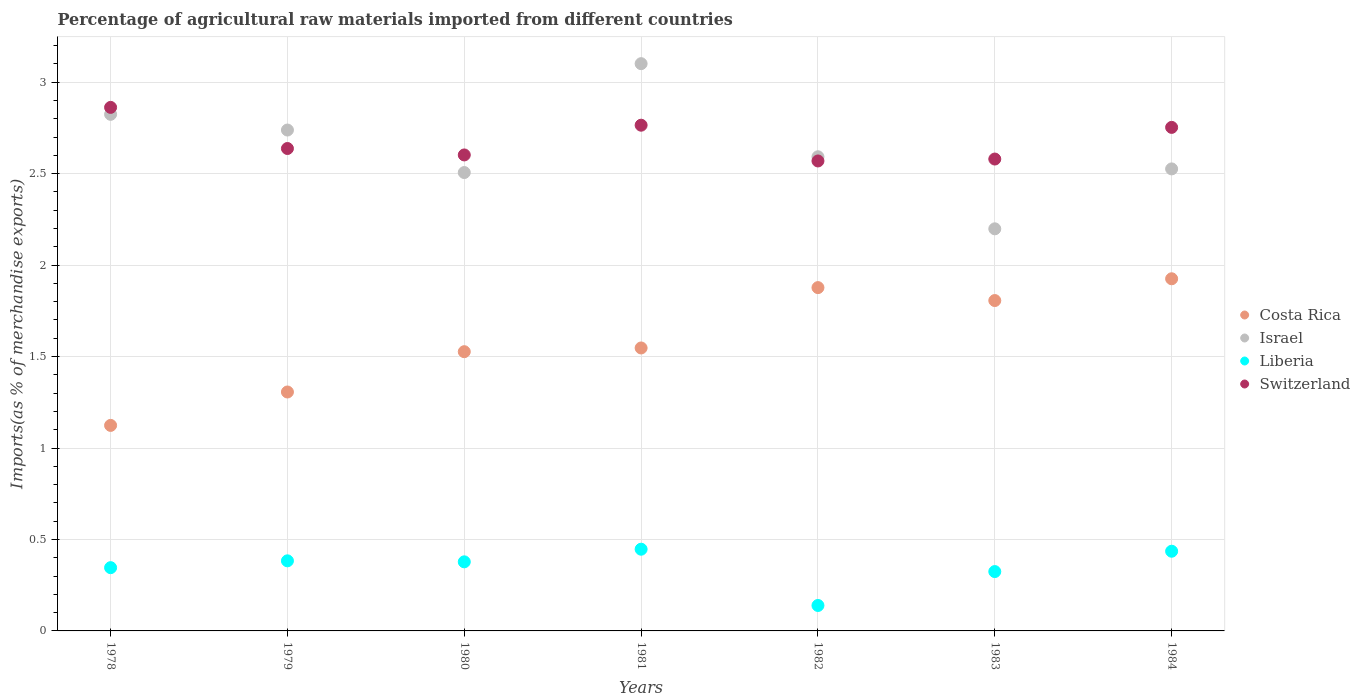What is the percentage of imports to different countries in Liberia in 1979?
Offer a terse response. 0.38. Across all years, what is the maximum percentage of imports to different countries in Costa Rica?
Your response must be concise. 1.93. Across all years, what is the minimum percentage of imports to different countries in Israel?
Your answer should be very brief. 2.2. In which year was the percentage of imports to different countries in Switzerland maximum?
Ensure brevity in your answer.  1978. In which year was the percentage of imports to different countries in Costa Rica minimum?
Keep it short and to the point. 1978. What is the total percentage of imports to different countries in Costa Rica in the graph?
Provide a succinct answer. 11.11. What is the difference between the percentage of imports to different countries in Costa Rica in 1978 and that in 1984?
Your response must be concise. -0.8. What is the difference between the percentage of imports to different countries in Israel in 1981 and the percentage of imports to different countries in Liberia in 1982?
Your answer should be very brief. 2.96. What is the average percentage of imports to different countries in Liberia per year?
Offer a terse response. 0.35. In the year 1979, what is the difference between the percentage of imports to different countries in Switzerland and percentage of imports to different countries in Israel?
Offer a very short reply. -0.1. In how many years, is the percentage of imports to different countries in Israel greater than 0.4 %?
Provide a succinct answer. 7. What is the ratio of the percentage of imports to different countries in Israel in 1979 to that in 1981?
Make the answer very short. 0.88. Is the difference between the percentage of imports to different countries in Switzerland in 1978 and 1983 greater than the difference between the percentage of imports to different countries in Israel in 1978 and 1983?
Your answer should be very brief. No. What is the difference between the highest and the second highest percentage of imports to different countries in Costa Rica?
Ensure brevity in your answer.  0.05. What is the difference between the highest and the lowest percentage of imports to different countries in Israel?
Your response must be concise. 0.9. Is the sum of the percentage of imports to different countries in Switzerland in 1979 and 1981 greater than the maximum percentage of imports to different countries in Costa Rica across all years?
Your answer should be very brief. Yes. What is the difference between two consecutive major ticks on the Y-axis?
Your answer should be very brief. 0.5. What is the title of the graph?
Your answer should be very brief. Percentage of agricultural raw materials imported from different countries. Does "Japan" appear as one of the legend labels in the graph?
Provide a succinct answer. No. What is the label or title of the X-axis?
Offer a terse response. Years. What is the label or title of the Y-axis?
Make the answer very short. Imports(as % of merchandise exports). What is the Imports(as % of merchandise exports) in Costa Rica in 1978?
Your response must be concise. 1.12. What is the Imports(as % of merchandise exports) of Israel in 1978?
Give a very brief answer. 2.82. What is the Imports(as % of merchandise exports) of Liberia in 1978?
Offer a terse response. 0.35. What is the Imports(as % of merchandise exports) in Switzerland in 1978?
Provide a succinct answer. 2.86. What is the Imports(as % of merchandise exports) in Costa Rica in 1979?
Keep it short and to the point. 1.31. What is the Imports(as % of merchandise exports) of Israel in 1979?
Provide a short and direct response. 2.74. What is the Imports(as % of merchandise exports) of Liberia in 1979?
Offer a terse response. 0.38. What is the Imports(as % of merchandise exports) in Switzerland in 1979?
Keep it short and to the point. 2.64. What is the Imports(as % of merchandise exports) of Costa Rica in 1980?
Keep it short and to the point. 1.53. What is the Imports(as % of merchandise exports) of Israel in 1980?
Offer a very short reply. 2.51. What is the Imports(as % of merchandise exports) of Liberia in 1980?
Make the answer very short. 0.38. What is the Imports(as % of merchandise exports) in Switzerland in 1980?
Your answer should be compact. 2.6. What is the Imports(as % of merchandise exports) in Costa Rica in 1981?
Your answer should be very brief. 1.55. What is the Imports(as % of merchandise exports) in Israel in 1981?
Give a very brief answer. 3.1. What is the Imports(as % of merchandise exports) of Liberia in 1981?
Make the answer very short. 0.45. What is the Imports(as % of merchandise exports) of Switzerland in 1981?
Keep it short and to the point. 2.76. What is the Imports(as % of merchandise exports) of Costa Rica in 1982?
Provide a short and direct response. 1.88. What is the Imports(as % of merchandise exports) in Israel in 1982?
Make the answer very short. 2.59. What is the Imports(as % of merchandise exports) in Liberia in 1982?
Offer a very short reply. 0.14. What is the Imports(as % of merchandise exports) of Switzerland in 1982?
Your answer should be very brief. 2.57. What is the Imports(as % of merchandise exports) in Costa Rica in 1983?
Your answer should be compact. 1.81. What is the Imports(as % of merchandise exports) in Israel in 1983?
Offer a terse response. 2.2. What is the Imports(as % of merchandise exports) in Liberia in 1983?
Provide a succinct answer. 0.32. What is the Imports(as % of merchandise exports) in Switzerland in 1983?
Provide a short and direct response. 2.58. What is the Imports(as % of merchandise exports) in Costa Rica in 1984?
Provide a succinct answer. 1.93. What is the Imports(as % of merchandise exports) of Israel in 1984?
Provide a succinct answer. 2.53. What is the Imports(as % of merchandise exports) in Liberia in 1984?
Your answer should be very brief. 0.44. What is the Imports(as % of merchandise exports) in Switzerland in 1984?
Offer a terse response. 2.75. Across all years, what is the maximum Imports(as % of merchandise exports) of Costa Rica?
Give a very brief answer. 1.93. Across all years, what is the maximum Imports(as % of merchandise exports) in Israel?
Provide a short and direct response. 3.1. Across all years, what is the maximum Imports(as % of merchandise exports) in Liberia?
Offer a very short reply. 0.45. Across all years, what is the maximum Imports(as % of merchandise exports) in Switzerland?
Offer a very short reply. 2.86. Across all years, what is the minimum Imports(as % of merchandise exports) of Costa Rica?
Your response must be concise. 1.12. Across all years, what is the minimum Imports(as % of merchandise exports) of Israel?
Provide a succinct answer. 2.2. Across all years, what is the minimum Imports(as % of merchandise exports) in Liberia?
Make the answer very short. 0.14. Across all years, what is the minimum Imports(as % of merchandise exports) of Switzerland?
Ensure brevity in your answer.  2.57. What is the total Imports(as % of merchandise exports) in Costa Rica in the graph?
Your answer should be very brief. 11.11. What is the total Imports(as % of merchandise exports) of Israel in the graph?
Offer a terse response. 18.49. What is the total Imports(as % of merchandise exports) of Liberia in the graph?
Offer a terse response. 2.45. What is the total Imports(as % of merchandise exports) in Switzerland in the graph?
Your answer should be very brief. 18.77. What is the difference between the Imports(as % of merchandise exports) of Costa Rica in 1978 and that in 1979?
Make the answer very short. -0.18. What is the difference between the Imports(as % of merchandise exports) of Israel in 1978 and that in 1979?
Ensure brevity in your answer.  0.09. What is the difference between the Imports(as % of merchandise exports) in Liberia in 1978 and that in 1979?
Give a very brief answer. -0.04. What is the difference between the Imports(as % of merchandise exports) of Switzerland in 1978 and that in 1979?
Give a very brief answer. 0.22. What is the difference between the Imports(as % of merchandise exports) of Costa Rica in 1978 and that in 1980?
Provide a succinct answer. -0.4. What is the difference between the Imports(as % of merchandise exports) of Israel in 1978 and that in 1980?
Make the answer very short. 0.32. What is the difference between the Imports(as % of merchandise exports) of Liberia in 1978 and that in 1980?
Offer a terse response. -0.03. What is the difference between the Imports(as % of merchandise exports) of Switzerland in 1978 and that in 1980?
Make the answer very short. 0.26. What is the difference between the Imports(as % of merchandise exports) in Costa Rica in 1978 and that in 1981?
Offer a very short reply. -0.42. What is the difference between the Imports(as % of merchandise exports) of Israel in 1978 and that in 1981?
Keep it short and to the point. -0.28. What is the difference between the Imports(as % of merchandise exports) of Liberia in 1978 and that in 1981?
Make the answer very short. -0.1. What is the difference between the Imports(as % of merchandise exports) in Switzerland in 1978 and that in 1981?
Provide a short and direct response. 0.1. What is the difference between the Imports(as % of merchandise exports) of Costa Rica in 1978 and that in 1982?
Your response must be concise. -0.75. What is the difference between the Imports(as % of merchandise exports) of Israel in 1978 and that in 1982?
Ensure brevity in your answer.  0.23. What is the difference between the Imports(as % of merchandise exports) of Liberia in 1978 and that in 1982?
Provide a succinct answer. 0.21. What is the difference between the Imports(as % of merchandise exports) of Switzerland in 1978 and that in 1982?
Your answer should be very brief. 0.29. What is the difference between the Imports(as % of merchandise exports) of Costa Rica in 1978 and that in 1983?
Your answer should be compact. -0.68. What is the difference between the Imports(as % of merchandise exports) in Israel in 1978 and that in 1983?
Your answer should be compact. 0.63. What is the difference between the Imports(as % of merchandise exports) of Liberia in 1978 and that in 1983?
Give a very brief answer. 0.02. What is the difference between the Imports(as % of merchandise exports) in Switzerland in 1978 and that in 1983?
Your answer should be compact. 0.28. What is the difference between the Imports(as % of merchandise exports) in Costa Rica in 1978 and that in 1984?
Provide a short and direct response. -0.8. What is the difference between the Imports(as % of merchandise exports) in Israel in 1978 and that in 1984?
Your answer should be very brief. 0.3. What is the difference between the Imports(as % of merchandise exports) of Liberia in 1978 and that in 1984?
Ensure brevity in your answer.  -0.09. What is the difference between the Imports(as % of merchandise exports) in Switzerland in 1978 and that in 1984?
Offer a terse response. 0.11. What is the difference between the Imports(as % of merchandise exports) in Costa Rica in 1979 and that in 1980?
Your response must be concise. -0.22. What is the difference between the Imports(as % of merchandise exports) of Israel in 1979 and that in 1980?
Provide a succinct answer. 0.23. What is the difference between the Imports(as % of merchandise exports) in Liberia in 1979 and that in 1980?
Provide a short and direct response. 0.01. What is the difference between the Imports(as % of merchandise exports) of Switzerland in 1979 and that in 1980?
Ensure brevity in your answer.  0.04. What is the difference between the Imports(as % of merchandise exports) of Costa Rica in 1979 and that in 1981?
Provide a short and direct response. -0.24. What is the difference between the Imports(as % of merchandise exports) in Israel in 1979 and that in 1981?
Ensure brevity in your answer.  -0.36. What is the difference between the Imports(as % of merchandise exports) in Liberia in 1979 and that in 1981?
Make the answer very short. -0.06. What is the difference between the Imports(as % of merchandise exports) of Switzerland in 1979 and that in 1981?
Offer a terse response. -0.13. What is the difference between the Imports(as % of merchandise exports) in Costa Rica in 1979 and that in 1982?
Keep it short and to the point. -0.57. What is the difference between the Imports(as % of merchandise exports) of Israel in 1979 and that in 1982?
Offer a very short reply. 0.15. What is the difference between the Imports(as % of merchandise exports) in Liberia in 1979 and that in 1982?
Offer a terse response. 0.24. What is the difference between the Imports(as % of merchandise exports) in Switzerland in 1979 and that in 1982?
Offer a terse response. 0.07. What is the difference between the Imports(as % of merchandise exports) in Costa Rica in 1979 and that in 1983?
Provide a short and direct response. -0.5. What is the difference between the Imports(as % of merchandise exports) in Israel in 1979 and that in 1983?
Provide a succinct answer. 0.54. What is the difference between the Imports(as % of merchandise exports) in Liberia in 1979 and that in 1983?
Keep it short and to the point. 0.06. What is the difference between the Imports(as % of merchandise exports) of Switzerland in 1979 and that in 1983?
Provide a succinct answer. 0.06. What is the difference between the Imports(as % of merchandise exports) of Costa Rica in 1979 and that in 1984?
Your answer should be very brief. -0.62. What is the difference between the Imports(as % of merchandise exports) of Israel in 1979 and that in 1984?
Make the answer very short. 0.21. What is the difference between the Imports(as % of merchandise exports) of Liberia in 1979 and that in 1984?
Keep it short and to the point. -0.05. What is the difference between the Imports(as % of merchandise exports) in Switzerland in 1979 and that in 1984?
Keep it short and to the point. -0.12. What is the difference between the Imports(as % of merchandise exports) in Costa Rica in 1980 and that in 1981?
Keep it short and to the point. -0.02. What is the difference between the Imports(as % of merchandise exports) in Israel in 1980 and that in 1981?
Ensure brevity in your answer.  -0.6. What is the difference between the Imports(as % of merchandise exports) of Liberia in 1980 and that in 1981?
Your answer should be very brief. -0.07. What is the difference between the Imports(as % of merchandise exports) of Switzerland in 1980 and that in 1981?
Offer a terse response. -0.16. What is the difference between the Imports(as % of merchandise exports) of Costa Rica in 1980 and that in 1982?
Your answer should be compact. -0.35. What is the difference between the Imports(as % of merchandise exports) of Israel in 1980 and that in 1982?
Give a very brief answer. -0.09. What is the difference between the Imports(as % of merchandise exports) of Liberia in 1980 and that in 1982?
Offer a terse response. 0.24. What is the difference between the Imports(as % of merchandise exports) of Switzerland in 1980 and that in 1982?
Your answer should be very brief. 0.03. What is the difference between the Imports(as % of merchandise exports) of Costa Rica in 1980 and that in 1983?
Provide a succinct answer. -0.28. What is the difference between the Imports(as % of merchandise exports) of Israel in 1980 and that in 1983?
Ensure brevity in your answer.  0.31. What is the difference between the Imports(as % of merchandise exports) in Liberia in 1980 and that in 1983?
Make the answer very short. 0.05. What is the difference between the Imports(as % of merchandise exports) in Switzerland in 1980 and that in 1983?
Your response must be concise. 0.02. What is the difference between the Imports(as % of merchandise exports) of Costa Rica in 1980 and that in 1984?
Provide a short and direct response. -0.4. What is the difference between the Imports(as % of merchandise exports) in Israel in 1980 and that in 1984?
Your answer should be compact. -0.02. What is the difference between the Imports(as % of merchandise exports) of Liberia in 1980 and that in 1984?
Your response must be concise. -0.06. What is the difference between the Imports(as % of merchandise exports) in Switzerland in 1980 and that in 1984?
Offer a terse response. -0.15. What is the difference between the Imports(as % of merchandise exports) of Costa Rica in 1981 and that in 1982?
Make the answer very short. -0.33. What is the difference between the Imports(as % of merchandise exports) of Israel in 1981 and that in 1982?
Provide a short and direct response. 0.51. What is the difference between the Imports(as % of merchandise exports) in Liberia in 1981 and that in 1982?
Offer a very short reply. 0.31. What is the difference between the Imports(as % of merchandise exports) of Switzerland in 1981 and that in 1982?
Keep it short and to the point. 0.2. What is the difference between the Imports(as % of merchandise exports) in Costa Rica in 1981 and that in 1983?
Your response must be concise. -0.26. What is the difference between the Imports(as % of merchandise exports) of Israel in 1981 and that in 1983?
Provide a succinct answer. 0.9. What is the difference between the Imports(as % of merchandise exports) in Liberia in 1981 and that in 1983?
Your answer should be compact. 0.12. What is the difference between the Imports(as % of merchandise exports) of Switzerland in 1981 and that in 1983?
Make the answer very short. 0.18. What is the difference between the Imports(as % of merchandise exports) of Costa Rica in 1981 and that in 1984?
Make the answer very short. -0.38. What is the difference between the Imports(as % of merchandise exports) of Israel in 1981 and that in 1984?
Give a very brief answer. 0.58. What is the difference between the Imports(as % of merchandise exports) in Liberia in 1981 and that in 1984?
Give a very brief answer. 0.01. What is the difference between the Imports(as % of merchandise exports) of Switzerland in 1981 and that in 1984?
Provide a succinct answer. 0.01. What is the difference between the Imports(as % of merchandise exports) of Costa Rica in 1982 and that in 1983?
Your answer should be compact. 0.07. What is the difference between the Imports(as % of merchandise exports) in Israel in 1982 and that in 1983?
Your answer should be compact. 0.39. What is the difference between the Imports(as % of merchandise exports) of Liberia in 1982 and that in 1983?
Your response must be concise. -0.19. What is the difference between the Imports(as % of merchandise exports) in Switzerland in 1982 and that in 1983?
Provide a short and direct response. -0.01. What is the difference between the Imports(as % of merchandise exports) in Costa Rica in 1982 and that in 1984?
Your response must be concise. -0.05. What is the difference between the Imports(as % of merchandise exports) of Israel in 1982 and that in 1984?
Offer a very short reply. 0.07. What is the difference between the Imports(as % of merchandise exports) of Liberia in 1982 and that in 1984?
Your answer should be very brief. -0.3. What is the difference between the Imports(as % of merchandise exports) of Switzerland in 1982 and that in 1984?
Provide a short and direct response. -0.18. What is the difference between the Imports(as % of merchandise exports) of Costa Rica in 1983 and that in 1984?
Keep it short and to the point. -0.12. What is the difference between the Imports(as % of merchandise exports) in Israel in 1983 and that in 1984?
Ensure brevity in your answer.  -0.33. What is the difference between the Imports(as % of merchandise exports) in Liberia in 1983 and that in 1984?
Offer a terse response. -0.11. What is the difference between the Imports(as % of merchandise exports) in Switzerland in 1983 and that in 1984?
Make the answer very short. -0.17. What is the difference between the Imports(as % of merchandise exports) in Costa Rica in 1978 and the Imports(as % of merchandise exports) in Israel in 1979?
Your response must be concise. -1.61. What is the difference between the Imports(as % of merchandise exports) of Costa Rica in 1978 and the Imports(as % of merchandise exports) of Liberia in 1979?
Give a very brief answer. 0.74. What is the difference between the Imports(as % of merchandise exports) in Costa Rica in 1978 and the Imports(as % of merchandise exports) in Switzerland in 1979?
Provide a short and direct response. -1.51. What is the difference between the Imports(as % of merchandise exports) in Israel in 1978 and the Imports(as % of merchandise exports) in Liberia in 1979?
Your answer should be very brief. 2.44. What is the difference between the Imports(as % of merchandise exports) of Israel in 1978 and the Imports(as % of merchandise exports) of Switzerland in 1979?
Your answer should be very brief. 0.19. What is the difference between the Imports(as % of merchandise exports) of Liberia in 1978 and the Imports(as % of merchandise exports) of Switzerland in 1979?
Your answer should be very brief. -2.29. What is the difference between the Imports(as % of merchandise exports) in Costa Rica in 1978 and the Imports(as % of merchandise exports) in Israel in 1980?
Provide a short and direct response. -1.38. What is the difference between the Imports(as % of merchandise exports) in Costa Rica in 1978 and the Imports(as % of merchandise exports) in Liberia in 1980?
Offer a terse response. 0.75. What is the difference between the Imports(as % of merchandise exports) in Costa Rica in 1978 and the Imports(as % of merchandise exports) in Switzerland in 1980?
Ensure brevity in your answer.  -1.48. What is the difference between the Imports(as % of merchandise exports) of Israel in 1978 and the Imports(as % of merchandise exports) of Liberia in 1980?
Your answer should be compact. 2.45. What is the difference between the Imports(as % of merchandise exports) of Israel in 1978 and the Imports(as % of merchandise exports) of Switzerland in 1980?
Offer a terse response. 0.22. What is the difference between the Imports(as % of merchandise exports) of Liberia in 1978 and the Imports(as % of merchandise exports) of Switzerland in 1980?
Provide a short and direct response. -2.26. What is the difference between the Imports(as % of merchandise exports) in Costa Rica in 1978 and the Imports(as % of merchandise exports) in Israel in 1981?
Your response must be concise. -1.98. What is the difference between the Imports(as % of merchandise exports) of Costa Rica in 1978 and the Imports(as % of merchandise exports) of Liberia in 1981?
Provide a short and direct response. 0.68. What is the difference between the Imports(as % of merchandise exports) of Costa Rica in 1978 and the Imports(as % of merchandise exports) of Switzerland in 1981?
Offer a very short reply. -1.64. What is the difference between the Imports(as % of merchandise exports) of Israel in 1978 and the Imports(as % of merchandise exports) of Liberia in 1981?
Your answer should be compact. 2.38. What is the difference between the Imports(as % of merchandise exports) in Israel in 1978 and the Imports(as % of merchandise exports) in Switzerland in 1981?
Provide a short and direct response. 0.06. What is the difference between the Imports(as % of merchandise exports) in Liberia in 1978 and the Imports(as % of merchandise exports) in Switzerland in 1981?
Ensure brevity in your answer.  -2.42. What is the difference between the Imports(as % of merchandise exports) in Costa Rica in 1978 and the Imports(as % of merchandise exports) in Israel in 1982?
Your answer should be compact. -1.47. What is the difference between the Imports(as % of merchandise exports) in Costa Rica in 1978 and the Imports(as % of merchandise exports) in Liberia in 1982?
Your answer should be very brief. 0.98. What is the difference between the Imports(as % of merchandise exports) of Costa Rica in 1978 and the Imports(as % of merchandise exports) of Switzerland in 1982?
Your answer should be compact. -1.45. What is the difference between the Imports(as % of merchandise exports) in Israel in 1978 and the Imports(as % of merchandise exports) in Liberia in 1982?
Your answer should be compact. 2.69. What is the difference between the Imports(as % of merchandise exports) of Israel in 1978 and the Imports(as % of merchandise exports) of Switzerland in 1982?
Offer a terse response. 0.26. What is the difference between the Imports(as % of merchandise exports) in Liberia in 1978 and the Imports(as % of merchandise exports) in Switzerland in 1982?
Provide a succinct answer. -2.22. What is the difference between the Imports(as % of merchandise exports) in Costa Rica in 1978 and the Imports(as % of merchandise exports) in Israel in 1983?
Offer a terse response. -1.07. What is the difference between the Imports(as % of merchandise exports) in Costa Rica in 1978 and the Imports(as % of merchandise exports) in Liberia in 1983?
Your response must be concise. 0.8. What is the difference between the Imports(as % of merchandise exports) in Costa Rica in 1978 and the Imports(as % of merchandise exports) in Switzerland in 1983?
Offer a very short reply. -1.46. What is the difference between the Imports(as % of merchandise exports) of Israel in 1978 and the Imports(as % of merchandise exports) of Liberia in 1983?
Give a very brief answer. 2.5. What is the difference between the Imports(as % of merchandise exports) in Israel in 1978 and the Imports(as % of merchandise exports) in Switzerland in 1983?
Your answer should be very brief. 0.24. What is the difference between the Imports(as % of merchandise exports) in Liberia in 1978 and the Imports(as % of merchandise exports) in Switzerland in 1983?
Your response must be concise. -2.23. What is the difference between the Imports(as % of merchandise exports) in Costa Rica in 1978 and the Imports(as % of merchandise exports) in Israel in 1984?
Give a very brief answer. -1.4. What is the difference between the Imports(as % of merchandise exports) of Costa Rica in 1978 and the Imports(as % of merchandise exports) of Liberia in 1984?
Offer a very short reply. 0.69. What is the difference between the Imports(as % of merchandise exports) of Costa Rica in 1978 and the Imports(as % of merchandise exports) of Switzerland in 1984?
Ensure brevity in your answer.  -1.63. What is the difference between the Imports(as % of merchandise exports) in Israel in 1978 and the Imports(as % of merchandise exports) in Liberia in 1984?
Provide a succinct answer. 2.39. What is the difference between the Imports(as % of merchandise exports) of Israel in 1978 and the Imports(as % of merchandise exports) of Switzerland in 1984?
Your response must be concise. 0.07. What is the difference between the Imports(as % of merchandise exports) in Liberia in 1978 and the Imports(as % of merchandise exports) in Switzerland in 1984?
Your answer should be compact. -2.41. What is the difference between the Imports(as % of merchandise exports) of Costa Rica in 1979 and the Imports(as % of merchandise exports) of Israel in 1980?
Make the answer very short. -1.2. What is the difference between the Imports(as % of merchandise exports) in Costa Rica in 1979 and the Imports(as % of merchandise exports) in Liberia in 1980?
Your answer should be compact. 0.93. What is the difference between the Imports(as % of merchandise exports) of Costa Rica in 1979 and the Imports(as % of merchandise exports) of Switzerland in 1980?
Provide a succinct answer. -1.3. What is the difference between the Imports(as % of merchandise exports) of Israel in 1979 and the Imports(as % of merchandise exports) of Liberia in 1980?
Provide a short and direct response. 2.36. What is the difference between the Imports(as % of merchandise exports) of Israel in 1979 and the Imports(as % of merchandise exports) of Switzerland in 1980?
Give a very brief answer. 0.14. What is the difference between the Imports(as % of merchandise exports) of Liberia in 1979 and the Imports(as % of merchandise exports) of Switzerland in 1980?
Provide a short and direct response. -2.22. What is the difference between the Imports(as % of merchandise exports) of Costa Rica in 1979 and the Imports(as % of merchandise exports) of Israel in 1981?
Offer a very short reply. -1.79. What is the difference between the Imports(as % of merchandise exports) of Costa Rica in 1979 and the Imports(as % of merchandise exports) of Liberia in 1981?
Make the answer very short. 0.86. What is the difference between the Imports(as % of merchandise exports) of Costa Rica in 1979 and the Imports(as % of merchandise exports) of Switzerland in 1981?
Make the answer very short. -1.46. What is the difference between the Imports(as % of merchandise exports) in Israel in 1979 and the Imports(as % of merchandise exports) in Liberia in 1981?
Ensure brevity in your answer.  2.29. What is the difference between the Imports(as % of merchandise exports) in Israel in 1979 and the Imports(as % of merchandise exports) in Switzerland in 1981?
Keep it short and to the point. -0.03. What is the difference between the Imports(as % of merchandise exports) of Liberia in 1979 and the Imports(as % of merchandise exports) of Switzerland in 1981?
Provide a short and direct response. -2.38. What is the difference between the Imports(as % of merchandise exports) of Costa Rica in 1979 and the Imports(as % of merchandise exports) of Israel in 1982?
Your answer should be compact. -1.29. What is the difference between the Imports(as % of merchandise exports) of Costa Rica in 1979 and the Imports(as % of merchandise exports) of Liberia in 1982?
Provide a succinct answer. 1.17. What is the difference between the Imports(as % of merchandise exports) of Costa Rica in 1979 and the Imports(as % of merchandise exports) of Switzerland in 1982?
Provide a succinct answer. -1.26. What is the difference between the Imports(as % of merchandise exports) of Israel in 1979 and the Imports(as % of merchandise exports) of Liberia in 1982?
Offer a terse response. 2.6. What is the difference between the Imports(as % of merchandise exports) of Israel in 1979 and the Imports(as % of merchandise exports) of Switzerland in 1982?
Keep it short and to the point. 0.17. What is the difference between the Imports(as % of merchandise exports) in Liberia in 1979 and the Imports(as % of merchandise exports) in Switzerland in 1982?
Provide a short and direct response. -2.19. What is the difference between the Imports(as % of merchandise exports) in Costa Rica in 1979 and the Imports(as % of merchandise exports) in Israel in 1983?
Give a very brief answer. -0.89. What is the difference between the Imports(as % of merchandise exports) in Costa Rica in 1979 and the Imports(as % of merchandise exports) in Liberia in 1983?
Your response must be concise. 0.98. What is the difference between the Imports(as % of merchandise exports) of Costa Rica in 1979 and the Imports(as % of merchandise exports) of Switzerland in 1983?
Ensure brevity in your answer.  -1.27. What is the difference between the Imports(as % of merchandise exports) in Israel in 1979 and the Imports(as % of merchandise exports) in Liberia in 1983?
Provide a short and direct response. 2.41. What is the difference between the Imports(as % of merchandise exports) in Israel in 1979 and the Imports(as % of merchandise exports) in Switzerland in 1983?
Offer a terse response. 0.16. What is the difference between the Imports(as % of merchandise exports) of Liberia in 1979 and the Imports(as % of merchandise exports) of Switzerland in 1983?
Your answer should be very brief. -2.2. What is the difference between the Imports(as % of merchandise exports) in Costa Rica in 1979 and the Imports(as % of merchandise exports) in Israel in 1984?
Provide a short and direct response. -1.22. What is the difference between the Imports(as % of merchandise exports) in Costa Rica in 1979 and the Imports(as % of merchandise exports) in Liberia in 1984?
Give a very brief answer. 0.87. What is the difference between the Imports(as % of merchandise exports) in Costa Rica in 1979 and the Imports(as % of merchandise exports) in Switzerland in 1984?
Provide a short and direct response. -1.45. What is the difference between the Imports(as % of merchandise exports) of Israel in 1979 and the Imports(as % of merchandise exports) of Liberia in 1984?
Your answer should be compact. 2.3. What is the difference between the Imports(as % of merchandise exports) of Israel in 1979 and the Imports(as % of merchandise exports) of Switzerland in 1984?
Your answer should be compact. -0.01. What is the difference between the Imports(as % of merchandise exports) of Liberia in 1979 and the Imports(as % of merchandise exports) of Switzerland in 1984?
Keep it short and to the point. -2.37. What is the difference between the Imports(as % of merchandise exports) in Costa Rica in 1980 and the Imports(as % of merchandise exports) in Israel in 1981?
Your response must be concise. -1.57. What is the difference between the Imports(as % of merchandise exports) of Costa Rica in 1980 and the Imports(as % of merchandise exports) of Liberia in 1981?
Give a very brief answer. 1.08. What is the difference between the Imports(as % of merchandise exports) of Costa Rica in 1980 and the Imports(as % of merchandise exports) of Switzerland in 1981?
Keep it short and to the point. -1.24. What is the difference between the Imports(as % of merchandise exports) of Israel in 1980 and the Imports(as % of merchandise exports) of Liberia in 1981?
Offer a very short reply. 2.06. What is the difference between the Imports(as % of merchandise exports) of Israel in 1980 and the Imports(as % of merchandise exports) of Switzerland in 1981?
Provide a succinct answer. -0.26. What is the difference between the Imports(as % of merchandise exports) in Liberia in 1980 and the Imports(as % of merchandise exports) in Switzerland in 1981?
Give a very brief answer. -2.39. What is the difference between the Imports(as % of merchandise exports) of Costa Rica in 1980 and the Imports(as % of merchandise exports) of Israel in 1982?
Make the answer very short. -1.07. What is the difference between the Imports(as % of merchandise exports) of Costa Rica in 1980 and the Imports(as % of merchandise exports) of Liberia in 1982?
Ensure brevity in your answer.  1.39. What is the difference between the Imports(as % of merchandise exports) of Costa Rica in 1980 and the Imports(as % of merchandise exports) of Switzerland in 1982?
Ensure brevity in your answer.  -1.04. What is the difference between the Imports(as % of merchandise exports) of Israel in 1980 and the Imports(as % of merchandise exports) of Liberia in 1982?
Make the answer very short. 2.37. What is the difference between the Imports(as % of merchandise exports) of Israel in 1980 and the Imports(as % of merchandise exports) of Switzerland in 1982?
Your answer should be very brief. -0.06. What is the difference between the Imports(as % of merchandise exports) in Liberia in 1980 and the Imports(as % of merchandise exports) in Switzerland in 1982?
Offer a terse response. -2.19. What is the difference between the Imports(as % of merchandise exports) of Costa Rica in 1980 and the Imports(as % of merchandise exports) of Israel in 1983?
Ensure brevity in your answer.  -0.67. What is the difference between the Imports(as % of merchandise exports) in Costa Rica in 1980 and the Imports(as % of merchandise exports) in Liberia in 1983?
Provide a short and direct response. 1.2. What is the difference between the Imports(as % of merchandise exports) in Costa Rica in 1980 and the Imports(as % of merchandise exports) in Switzerland in 1983?
Make the answer very short. -1.05. What is the difference between the Imports(as % of merchandise exports) of Israel in 1980 and the Imports(as % of merchandise exports) of Liberia in 1983?
Provide a short and direct response. 2.18. What is the difference between the Imports(as % of merchandise exports) of Israel in 1980 and the Imports(as % of merchandise exports) of Switzerland in 1983?
Ensure brevity in your answer.  -0.07. What is the difference between the Imports(as % of merchandise exports) in Liberia in 1980 and the Imports(as % of merchandise exports) in Switzerland in 1983?
Provide a short and direct response. -2.2. What is the difference between the Imports(as % of merchandise exports) in Costa Rica in 1980 and the Imports(as % of merchandise exports) in Israel in 1984?
Provide a short and direct response. -1. What is the difference between the Imports(as % of merchandise exports) in Costa Rica in 1980 and the Imports(as % of merchandise exports) in Liberia in 1984?
Offer a terse response. 1.09. What is the difference between the Imports(as % of merchandise exports) of Costa Rica in 1980 and the Imports(as % of merchandise exports) of Switzerland in 1984?
Your answer should be very brief. -1.23. What is the difference between the Imports(as % of merchandise exports) of Israel in 1980 and the Imports(as % of merchandise exports) of Liberia in 1984?
Your answer should be very brief. 2.07. What is the difference between the Imports(as % of merchandise exports) in Israel in 1980 and the Imports(as % of merchandise exports) in Switzerland in 1984?
Your answer should be very brief. -0.25. What is the difference between the Imports(as % of merchandise exports) of Liberia in 1980 and the Imports(as % of merchandise exports) of Switzerland in 1984?
Give a very brief answer. -2.38. What is the difference between the Imports(as % of merchandise exports) of Costa Rica in 1981 and the Imports(as % of merchandise exports) of Israel in 1982?
Offer a very short reply. -1.05. What is the difference between the Imports(as % of merchandise exports) of Costa Rica in 1981 and the Imports(as % of merchandise exports) of Liberia in 1982?
Make the answer very short. 1.41. What is the difference between the Imports(as % of merchandise exports) of Costa Rica in 1981 and the Imports(as % of merchandise exports) of Switzerland in 1982?
Offer a terse response. -1.02. What is the difference between the Imports(as % of merchandise exports) in Israel in 1981 and the Imports(as % of merchandise exports) in Liberia in 1982?
Your response must be concise. 2.96. What is the difference between the Imports(as % of merchandise exports) in Israel in 1981 and the Imports(as % of merchandise exports) in Switzerland in 1982?
Keep it short and to the point. 0.53. What is the difference between the Imports(as % of merchandise exports) in Liberia in 1981 and the Imports(as % of merchandise exports) in Switzerland in 1982?
Your answer should be very brief. -2.12. What is the difference between the Imports(as % of merchandise exports) of Costa Rica in 1981 and the Imports(as % of merchandise exports) of Israel in 1983?
Keep it short and to the point. -0.65. What is the difference between the Imports(as % of merchandise exports) of Costa Rica in 1981 and the Imports(as % of merchandise exports) of Liberia in 1983?
Ensure brevity in your answer.  1.22. What is the difference between the Imports(as % of merchandise exports) of Costa Rica in 1981 and the Imports(as % of merchandise exports) of Switzerland in 1983?
Offer a very short reply. -1.03. What is the difference between the Imports(as % of merchandise exports) in Israel in 1981 and the Imports(as % of merchandise exports) in Liberia in 1983?
Offer a terse response. 2.78. What is the difference between the Imports(as % of merchandise exports) in Israel in 1981 and the Imports(as % of merchandise exports) in Switzerland in 1983?
Provide a succinct answer. 0.52. What is the difference between the Imports(as % of merchandise exports) in Liberia in 1981 and the Imports(as % of merchandise exports) in Switzerland in 1983?
Offer a very short reply. -2.13. What is the difference between the Imports(as % of merchandise exports) of Costa Rica in 1981 and the Imports(as % of merchandise exports) of Israel in 1984?
Keep it short and to the point. -0.98. What is the difference between the Imports(as % of merchandise exports) of Costa Rica in 1981 and the Imports(as % of merchandise exports) of Liberia in 1984?
Provide a succinct answer. 1.11. What is the difference between the Imports(as % of merchandise exports) in Costa Rica in 1981 and the Imports(as % of merchandise exports) in Switzerland in 1984?
Keep it short and to the point. -1.21. What is the difference between the Imports(as % of merchandise exports) of Israel in 1981 and the Imports(as % of merchandise exports) of Liberia in 1984?
Make the answer very short. 2.67. What is the difference between the Imports(as % of merchandise exports) in Israel in 1981 and the Imports(as % of merchandise exports) in Switzerland in 1984?
Your answer should be compact. 0.35. What is the difference between the Imports(as % of merchandise exports) of Liberia in 1981 and the Imports(as % of merchandise exports) of Switzerland in 1984?
Offer a terse response. -2.31. What is the difference between the Imports(as % of merchandise exports) in Costa Rica in 1982 and the Imports(as % of merchandise exports) in Israel in 1983?
Provide a short and direct response. -0.32. What is the difference between the Imports(as % of merchandise exports) of Costa Rica in 1982 and the Imports(as % of merchandise exports) of Liberia in 1983?
Provide a succinct answer. 1.55. What is the difference between the Imports(as % of merchandise exports) of Costa Rica in 1982 and the Imports(as % of merchandise exports) of Switzerland in 1983?
Offer a very short reply. -0.7. What is the difference between the Imports(as % of merchandise exports) of Israel in 1982 and the Imports(as % of merchandise exports) of Liberia in 1983?
Provide a short and direct response. 2.27. What is the difference between the Imports(as % of merchandise exports) of Israel in 1982 and the Imports(as % of merchandise exports) of Switzerland in 1983?
Offer a very short reply. 0.01. What is the difference between the Imports(as % of merchandise exports) of Liberia in 1982 and the Imports(as % of merchandise exports) of Switzerland in 1983?
Give a very brief answer. -2.44. What is the difference between the Imports(as % of merchandise exports) in Costa Rica in 1982 and the Imports(as % of merchandise exports) in Israel in 1984?
Keep it short and to the point. -0.65. What is the difference between the Imports(as % of merchandise exports) of Costa Rica in 1982 and the Imports(as % of merchandise exports) of Liberia in 1984?
Offer a very short reply. 1.44. What is the difference between the Imports(as % of merchandise exports) in Costa Rica in 1982 and the Imports(as % of merchandise exports) in Switzerland in 1984?
Your answer should be compact. -0.88. What is the difference between the Imports(as % of merchandise exports) of Israel in 1982 and the Imports(as % of merchandise exports) of Liberia in 1984?
Provide a short and direct response. 2.16. What is the difference between the Imports(as % of merchandise exports) in Israel in 1982 and the Imports(as % of merchandise exports) in Switzerland in 1984?
Your answer should be compact. -0.16. What is the difference between the Imports(as % of merchandise exports) in Liberia in 1982 and the Imports(as % of merchandise exports) in Switzerland in 1984?
Provide a short and direct response. -2.61. What is the difference between the Imports(as % of merchandise exports) of Costa Rica in 1983 and the Imports(as % of merchandise exports) of Israel in 1984?
Offer a very short reply. -0.72. What is the difference between the Imports(as % of merchandise exports) in Costa Rica in 1983 and the Imports(as % of merchandise exports) in Liberia in 1984?
Give a very brief answer. 1.37. What is the difference between the Imports(as % of merchandise exports) in Costa Rica in 1983 and the Imports(as % of merchandise exports) in Switzerland in 1984?
Your response must be concise. -0.95. What is the difference between the Imports(as % of merchandise exports) in Israel in 1983 and the Imports(as % of merchandise exports) in Liberia in 1984?
Make the answer very short. 1.76. What is the difference between the Imports(as % of merchandise exports) in Israel in 1983 and the Imports(as % of merchandise exports) in Switzerland in 1984?
Offer a terse response. -0.55. What is the difference between the Imports(as % of merchandise exports) of Liberia in 1983 and the Imports(as % of merchandise exports) of Switzerland in 1984?
Keep it short and to the point. -2.43. What is the average Imports(as % of merchandise exports) of Costa Rica per year?
Provide a succinct answer. 1.59. What is the average Imports(as % of merchandise exports) of Israel per year?
Your answer should be compact. 2.64. What is the average Imports(as % of merchandise exports) in Liberia per year?
Your answer should be compact. 0.35. What is the average Imports(as % of merchandise exports) of Switzerland per year?
Your answer should be very brief. 2.68. In the year 1978, what is the difference between the Imports(as % of merchandise exports) of Costa Rica and Imports(as % of merchandise exports) of Israel?
Give a very brief answer. -1.7. In the year 1978, what is the difference between the Imports(as % of merchandise exports) of Costa Rica and Imports(as % of merchandise exports) of Switzerland?
Your answer should be compact. -1.74. In the year 1978, what is the difference between the Imports(as % of merchandise exports) in Israel and Imports(as % of merchandise exports) in Liberia?
Your answer should be very brief. 2.48. In the year 1978, what is the difference between the Imports(as % of merchandise exports) of Israel and Imports(as % of merchandise exports) of Switzerland?
Your answer should be compact. -0.04. In the year 1978, what is the difference between the Imports(as % of merchandise exports) in Liberia and Imports(as % of merchandise exports) in Switzerland?
Give a very brief answer. -2.52. In the year 1979, what is the difference between the Imports(as % of merchandise exports) of Costa Rica and Imports(as % of merchandise exports) of Israel?
Your answer should be very brief. -1.43. In the year 1979, what is the difference between the Imports(as % of merchandise exports) in Costa Rica and Imports(as % of merchandise exports) in Liberia?
Offer a terse response. 0.92. In the year 1979, what is the difference between the Imports(as % of merchandise exports) of Costa Rica and Imports(as % of merchandise exports) of Switzerland?
Your answer should be compact. -1.33. In the year 1979, what is the difference between the Imports(as % of merchandise exports) of Israel and Imports(as % of merchandise exports) of Liberia?
Keep it short and to the point. 2.36. In the year 1979, what is the difference between the Imports(as % of merchandise exports) in Israel and Imports(as % of merchandise exports) in Switzerland?
Make the answer very short. 0.1. In the year 1979, what is the difference between the Imports(as % of merchandise exports) in Liberia and Imports(as % of merchandise exports) in Switzerland?
Offer a terse response. -2.25. In the year 1980, what is the difference between the Imports(as % of merchandise exports) of Costa Rica and Imports(as % of merchandise exports) of Israel?
Ensure brevity in your answer.  -0.98. In the year 1980, what is the difference between the Imports(as % of merchandise exports) of Costa Rica and Imports(as % of merchandise exports) of Liberia?
Offer a terse response. 1.15. In the year 1980, what is the difference between the Imports(as % of merchandise exports) in Costa Rica and Imports(as % of merchandise exports) in Switzerland?
Provide a short and direct response. -1.08. In the year 1980, what is the difference between the Imports(as % of merchandise exports) of Israel and Imports(as % of merchandise exports) of Liberia?
Keep it short and to the point. 2.13. In the year 1980, what is the difference between the Imports(as % of merchandise exports) in Israel and Imports(as % of merchandise exports) in Switzerland?
Offer a terse response. -0.1. In the year 1980, what is the difference between the Imports(as % of merchandise exports) of Liberia and Imports(as % of merchandise exports) of Switzerland?
Your response must be concise. -2.22. In the year 1981, what is the difference between the Imports(as % of merchandise exports) in Costa Rica and Imports(as % of merchandise exports) in Israel?
Ensure brevity in your answer.  -1.55. In the year 1981, what is the difference between the Imports(as % of merchandise exports) of Costa Rica and Imports(as % of merchandise exports) of Liberia?
Keep it short and to the point. 1.1. In the year 1981, what is the difference between the Imports(as % of merchandise exports) in Costa Rica and Imports(as % of merchandise exports) in Switzerland?
Ensure brevity in your answer.  -1.22. In the year 1981, what is the difference between the Imports(as % of merchandise exports) in Israel and Imports(as % of merchandise exports) in Liberia?
Your response must be concise. 2.65. In the year 1981, what is the difference between the Imports(as % of merchandise exports) in Israel and Imports(as % of merchandise exports) in Switzerland?
Give a very brief answer. 0.34. In the year 1981, what is the difference between the Imports(as % of merchandise exports) in Liberia and Imports(as % of merchandise exports) in Switzerland?
Your response must be concise. -2.32. In the year 1982, what is the difference between the Imports(as % of merchandise exports) of Costa Rica and Imports(as % of merchandise exports) of Israel?
Keep it short and to the point. -0.72. In the year 1982, what is the difference between the Imports(as % of merchandise exports) in Costa Rica and Imports(as % of merchandise exports) in Liberia?
Your answer should be very brief. 1.74. In the year 1982, what is the difference between the Imports(as % of merchandise exports) in Costa Rica and Imports(as % of merchandise exports) in Switzerland?
Ensure brevity in your answer.  -0.69. In the year 1982, what is the difference between the Imports(as % of merchandise exports) in Israel and Imports(as % of merchandise exports) in Liberia?
Ensure brevity in your answer.  2.45. In the year 1982, what is the difference between the Imports(as % of merchandise exports) in Israel and Imports(as % of merchandise exports) in Switzerland?
Ensure brevity in your answer.  0.02. In the year 1982, what is the difference between the Imports(as % of merchandise exports) of Liberia and Imports(as % of merchandise exports) of Switzerland?
Give a very brief answer. -2.43. In the year 1983, what is the difference between the Imports(as % of merchandise exports) in Costa Rica and Imports(as % of merchandise exports) in Israel?
Offer a terse response. -0.39. In the year 1983, what is the difference between the Imports(as % of merchandise exports) of Costa Rica and Imports(as % of merchandise exports) of Liberia?
Your answer should be compact. 1.48. In the year 1983, what is the difference between the Imports(as % of merchandise exports) in Costa Rica and Imports(as % of merchandise exports) in Switzerland?
Your answer should be compact. -0.77. In the year 1983, what is the difference between the Imports(as % of merchandise exports) in Israel and Imports(as % of merchandise exports) in Liberia?
Make the answer very short. 1.87. In the year 1983, what is the difference between the Imports(as % of merchandise exports) in Israel and Imports(as % of merchandise exports) in Switzerland?
Your answer should be compact. -0.38. In the year 1983, what is the difference between the Imports(as % of merchandise exports) of Liberia and Imports(as % of merchandise exports) of Switzerland?
Offer a terse response. -2.26. In the year 1984, what is the difference between the Imports(as % of merchandise exports) in Costa Rica and Imports(as % of merchandise exports) in Israel?
Make the answer very short. -0.6. In the year 1984, what is the difference between the Imports(as % of merchandise exports) of Costa Rica and Imports(as % of merchandise exports) of Liberia?
Your answer should be compact. 1.49. In the year 1984, what is the difference between the Imports(as % of merchandise exports) in Costa Rica and Imports(as % of merchandise exports) in Switzerland?
Offer a very short reply. -0.83. In the year 1984, what is the difference between the Imports(as % of merchandise exports) in Israel and Imports(as % of merchandise exports) in Liberia?
Offer a terse response. 2.09. In the year 1984, what is the difference between the Imports(as % of merchandise exports) of Israel and Imports(as % of merchandise exports) of Switzerland?
Your answer should be compact. -0.23. In the year 1984, what is the difference between the Imports(as % of merchandise exports) of Liberia and Imports(as % of merchandise exports) of Switzerland?
Give a very brief answer. -2.32. What is the ratio of the Imports(as % of merchandise exports) of Costa Rica in 1978 to that in 1979?
Give a very brief answer. 0.86. What is the ratio of the Imports(as % of merchandise exports) of Israel in 1978 to that in 1979?
Give a very brief answer. 1.03. What is the ratio of the Imports(as % of merchandise exports) in Liberia in 1978 to that in 1979?
Your answer should be compact. 0.9. What is the ratio of the Imports(as % of merchandise exports) of Switzerland in 1978 to that in 1979?
Your response must be concise. 1.09. What is the ratio of the Imports(as % of merchandise exports) in Costa Rica in 1978 to that in 1980?
Keep it short and to the point. 0.74. What is the ratio of the Imports(as % of merchandise exports) of Israel in 1978 to that in 1980?
Keep it short and to the point. 1.13. What is the ratio of the Imports(as % of merchandise exports) in Liberia in 1978 to that in 1980?
Provide a succinct answer. 0.92. What is the ratio of the Imports(as % of merchandise exports) of Switzerland in 1978 to that in 1980?
Ensure brevity in your answer.  1.1. What is the ratio of the Imports(as % of merchandise exports) in Costa Rica in 1978 to that in 1981?
Ensure brevity in your answer.  0.73. What is the ratio of the Imports(as % of merchandise exports) in Israel in 1978 to that in 1981?
Offer a very short reply. 0.91. What is the ratio of the Imports(as % of merchandise exports) of Liberia in 1978 to that in 1981?
Provide a short and direct response. 0.77. What is the ratio of the Imports(as % of merchandise exports) in Switzerland in 1978 to that in 1981?
Offer a very short reply. 1.04. What is the ratio of the Imports(as % of merchandise exports) of Costa Rica in 1978 to that in 1982?
Provide a short and direct response. 0.6. What is the ratio of the Imports(as % of merchandise exports) of Israel in 1978 to that in 1982?
Give a very brief answer. 1.09. What is the ratio of the Imports(as % of merchandise exports) in Liberia in 1978 to that in 1982?
Your answer should be very brief. 2.49. What is the ratio of the Imports(as % of merchandise exports) of Switzerland in 1978 to that in 1982?
Your response must be concise. 1.11. What is the ratio of the Imports(as % of merchandise exports) in Costa Rica in 1978 to that in 1983?
Give a very brief answer. 0.62. What is the ratio of the Imports(as % of merchandise exports) in Israel in 1978 to that in 1983?
Your answer should be compact. 1.28. What is the ratio of the Imports(as % of merchandise exports) in Liberia in 1978 to that in 1983?
Give a very brief answer. 1.07. What is the ratio of the Imports(as % of merchandise exports) in Switzerland in 1978 to that in 1983?
Provide a succinct answer. 1.11. What is the ratio of the Imports(as % of merchandise exports) in Costa Rica in 1978 to that in 1984?
Give a very brief answer. 0.58. What is the ratio of the Imports(as % of merchandise exports) in Israel in 1978 to that in 1984?
Your response must be concise. 1.12. What is the ratio of the Imports(as % of merchandise exports) of Liberia in 1978 to that in 1984?
Give a very brief answer. 0.79. What is the ratio of the Imports(as % of merchandise exports) in Switzerland in 1978 to that in 1984?
Provide a succinct answer. 1.04. What is the ratio of the Imports(as % of merchandise exports) of Costa Rica in 1979 to that in 1980?
Offer a very short reply. 0.86. What is the ratio of the Imports(as % of merchandise exports) of Israel in 1979 to that in 1980?
Keep it short and to the point. 1.09. What is the ratio of the Imports(as % of merchandise exports) in Liberia in 1979 to that in 1980?
Give a very brief answer. 1.01. What is the ratio of the Imports(as % of merchandise exports) in Switzerland in 1979 to that in 1980?
Ensure brevity in your answer.  1.01. What is the ratio of the Imports(as % of merchandise exports) in Costa Rica in 1979 to that in 1981?
Keep it short and to the point. 0.84. What is the ratio of the Imports(as % of merchandise exports) in Israel in 1979 to that in 1981?
Offer a terse response. 0.88. What is the ratio of the Imports(as % of merchandise exports) in Liberia in 1979 to that in 1981?
Ensure brevity in your answer.  0.86. What is the ratio of the Imports(as % of merchandise exports) of Switzerland in 1979 to that in 1981?
Your answer should be very brief. 0.95. What is the ratio of the Imports(as % of merchandise exports) in Costa Rica in 1979 to that in 1982?
Give a very brief answer. 0.7. What is the ratio of the Imports(as % of merchandise exports) of Israel in 1979 to that in 1982?
Provide a succinct answer. 1.06. What is the ratio of the Imports(as % of merchandise exports) in Liberia in 1979 to that in 1982?
Your answer should be very brief. 2.75. What is the ratio of the Imports(as % of merchandise exports) of Switzerland in 1979 to that in 1982?
Provide a succinct answer. 1.03. What is the ratio of the Imports(as % of merchandise exports) in Costa Rica in 1979 to that in 1983?
Your answer should be compact. 0.72. What is the ratio of the Imports(as % of merchandise exports) of Israel in 1979 to that in 1983?
Your response must be concise. 1.25. What is the ratio of the Imports(as % of merchandise exports) of Liberia in 1979 to that in 1983?
Your response must be concise. 1.18. What is the ratio of the Imports(as % of merchandise exports) in Switzerland in 1979 to that in 1983?
Keep it short and to the point. 1.02. What is the ratio of the Imports(as % of merchandise exports) of Costa Rica in 1979 to that in 1984?
Provide a succinct answer. 0.68. What is the ratio of the Imports(as % of merchandise exports) in Israel in 1979 to that in 1984?
Keep it short and to the point. 1.08. What is the ratio of the Imports(as % of merchandise exports) of Liberia in 1979 to that in 1984?
Provide a succinct answer. 0.88. What is the ratio of the Imports(as % of merchandise exports) in Switzerland in 1979 to that in 1984?
Provide a succinct answer. 0.96. What is the ratio of the Imports(as % of merchandise exports) of Israel in 1980 to that in 1981?
Keep it short and to the point. 0.81. What is the ratio of the Imports(as % of merchandise exports) of Liberia in 1980 to that in 1981?
Make the answer very short. 0.85. What is the ratio of the Imports(as % of merchandise exports) in Costa Rica in 1980 to that in 1982?
Provide a succinct answer. 0.81. What is the ratio of the Imports(as % of merchandise exports) in Israel in 1980 to that in 1982?
Offer a very short reply. 0.97. What is the ratio of the Imports(as % of merchandise exports) in Liberia in 1980 to that in 1982?
Keep it short and to the point. 2.71. What is the ratio of the Imports(as % of merchandise exports) in Switzerland in 1980 to that in 1982?
Keep it short and to the point. 1.01. What is the ratio of the Imports(as % of merchandise exports) in Costa Rica in 1980 to that in 1983?
Offer a very short reply. 0.85. What is the ratio of the Imports(as % of merchandise exports) of Israel in 1980 to that in 1983?
Your answer should be very brief. 1.14. What is the ratio of the Imports(as % of merchandise exports) in Liberia in 1980 to that in 1983?
Keep it short and to the point. 1.16. What is the ratio of the Imports(as % of merchandise exports) of Switzerland in 1980 to that in 1983?
Your answer should be very brief. 1.01. What is the ratio of the Imports(as % of merchandise exports) of Costa Rica in 1980 to that in 1984?
Your answer should be compact. 0.79. What is the ratio of the Imports(as % of merchandise exports) of Liberia in 1980 to that in 1984?
Offer a terse response. 0.87. What is the ratio of the Imports(as % of merchandise exports) of Switzerland in 1980 to that in 1984?
Your answer should be very brief. 0.95. What is the ratio of the Imports(as % of merchandise exports) of Costa Rica in 1981 to that in 1982?
Your answer should be very brief. 0.82. What is the ratio of the Imports(as % of merchandise exports) in Israel in 1981 to that in 1982?
Provide a short and direct response. 1.2. What is the ratio of the Imports(as % of merchandise exports) in Liberia in 1981 to that in 1982?
Offer a terse response. 3.21. What is the ratio of the Imports(as % of merchandise exports) in Switzerland in 1981 to that in 1982?
Offer a terse response. 1.08. What is the ratio of the Imports(as % of merchandise exports) of Costa Rica in 1981 to that in 1983?
Ensure brevity in your answer.  0.86. What is the ratio of the Imports(as % of merchandise exports) of Israel in 1981 to that in 1983?
Give a very brief answer. 1.41. What is the ratio of the Imports(as % of merchandise exports) in Liberia in 1981 to that in 1983?
Provide a short and direct response. 1.38. What is the ratio of the Imports(as % of merchandise exports) in Switzerland in 1981 to that in 1983?
Your response must be concise. 1.07. What is the ratio of the Imports(as % of merchandise exports) of Costa Rica in 1981 to that in 1984?
Ensure brevity in your answer.  0.8. What is the ratio of the Imports(as % of merchandise exports) of Israel in 1981 to that in 1984?
Keep it short and to the point. 1.23. What is the ratio of the Imports(as % of merchandise exports) of Liberia in 1981 to that in 1984?
Your answer should be compact. 1.03. What is the ratio of the Imports(as % of merchandise exports) in Switzerland in 1981 to that in 1984?
Your response must be concise. 1. What is the ratio of the Imports(as % of merchandise exports) of Costa Rica in 1982 to that in 1983?
Your response must be concise. 1.04. What is the ratio of the Imports(as % of merchandise exports) of Israel in 1982 to that in 1983?
Provide a short and direct response. 1.18. What is the ratio of the Imports(as % of merchandise exports) in Liberia in 1982 to that in 1983?
Offer a very short reply. 0.43. What is the ratio of the Imports(as % of merchandise exports) of Switzerland in 1982 to that in 1983?
Your answer should be compact. 1. What is the ratio of the Imports(as % of merchandise exports) in Costa Rica in 1982 to that in 1984?
Your response must be concise. 0.97. What is the ratio of the Imports(as % of merchandise exports) of Israel in 1982 to that in 1984?
Ensure brevity in your answer.  1.03. What is the ratio of the Imports(as % of merchandise exports) in Liberia in 1982 to that in 1984?
Keep it short and to the point. 0.32. What is the ratio of the Imports(as % of merchandise exports) in Switzerland in 1982 to that in 1984?
Ensure brevity in your answer.  0.93. What is the ratio of the Imports(as % of merchandise exports) in Costa Rica in 1983 to that in 1984?
Make the answer very short. 0.94. What is the ratio of the Imports(as % of merchandise exports) of Israel in 1983 to that in 1984?
Give a very brief answer. 0.87. What is the ratio of the Imports(as % of merchandise exports) of Liberia in 1983 to that in 1984?
Your answer should be compact. 0.74. What is the ratio of the Imports(as % of merchandise exports) in Switzerland in 1983 to that in 1984?
Provide a short and direct response. 0.94. What is the difference between the highest and the second highest Imports(as % of merchandise exports) of Costa Rica?
Keep it short and to the point. 0.05. What is the difference between the highest and the second highest Imports(as % of merchandise exports) of Israel?
Your answer should be very brief. 0.28. What is the difference between the highest and the second highest Imports(as % of merchandise exports) of Liberia?
Give a very brief answer. 0.01. What is the difference between the highest and the second highest Imports(as % of merchandise exports) in Switzerland?
Offer a very short reply. 0.1. What is the difference between the highest and the lowest Imports(as % of merchandise exports) of Costa Rica?
Make the answer very short. 0.8. What is the difference between the highest and the lowest Imports(as % of merchandise exports) in Israel?
Your answer should be compact. 0.9. What is the difference between the highest and the lowest Imports(as % of merchandise exports) of Liberia?
Offer a very short reply. 0.31. What is the difference between the highest and the lowest Imports(as % of merchandise exports) of Switzerland?
Ensure brevity in your answer.  0.29. 